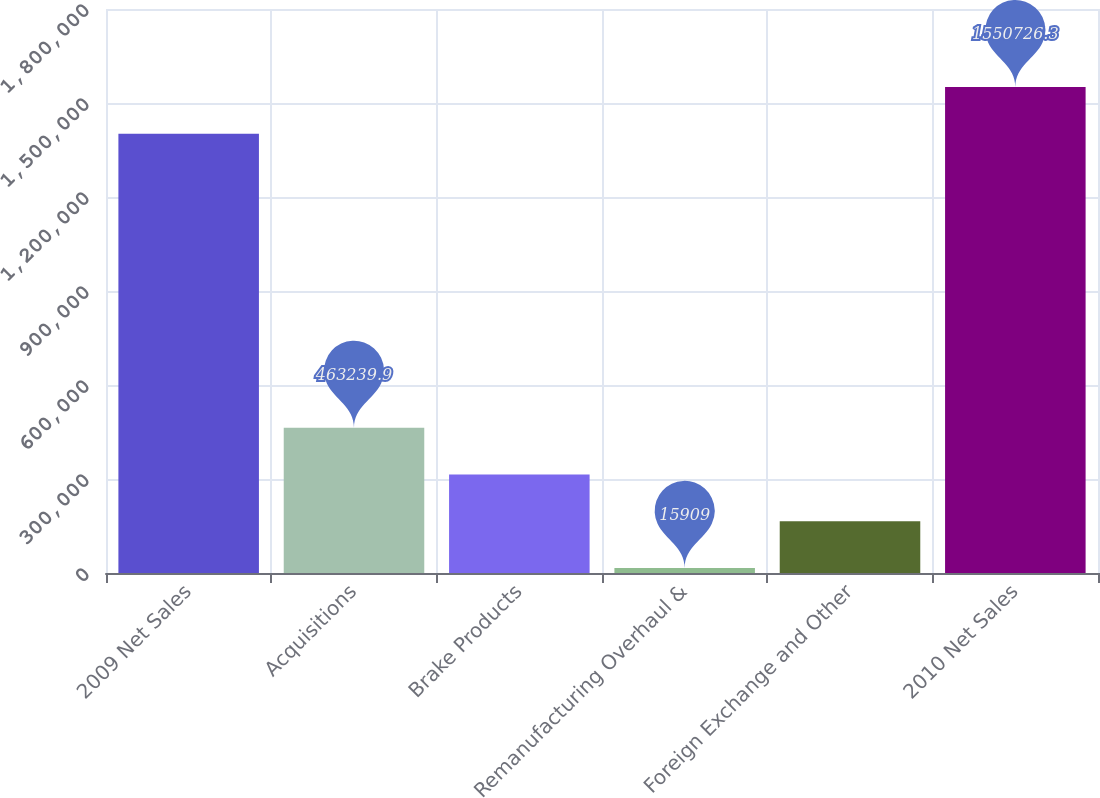<chart> <loc_0><loc_0><loc_500><loc_500><bar_chart><fcel>2009 Net Sales<fcel>Acquisitions<fcel>Brake Products<fcel>Remanufacturing Overhaul &<fcel>Foreign Exchange and Other<fcel>2010 Net Sales<nl><fcel>1.40162e+06<fcel>463240<fcel>314130<fcel>15909<fcel>165019<fcel>1.55073e+06<nl></chart> 